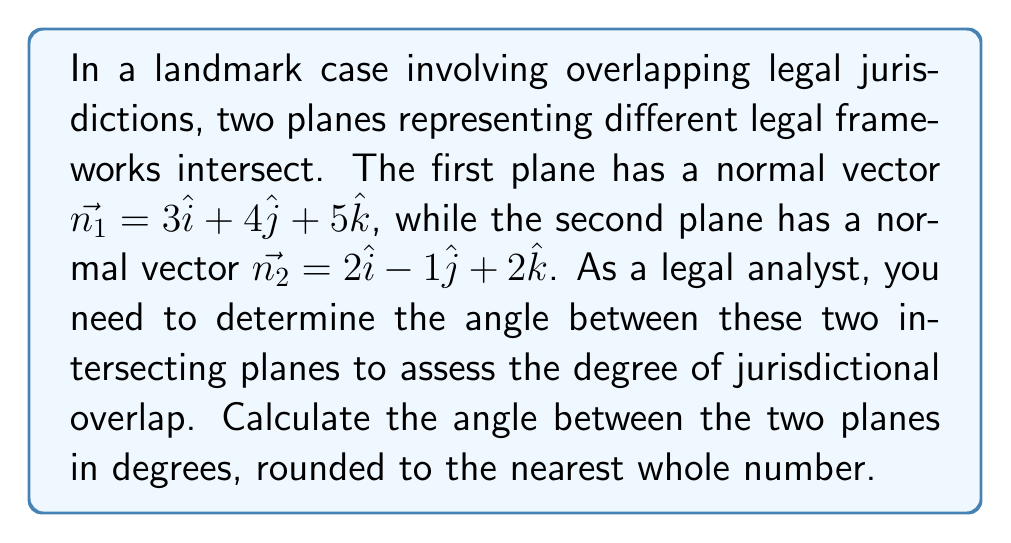What is the answer to this math problem? To find the angle between two intersecting planes, we can use the angle between their normal vectors. The formula for the angle $\theta$ between two vectors $\vec{a}$ and $\vec{b}$ is:

$$\cos \theta = \frac{\vec{a} \cdot \vec{b}}{|\vec{a}||\vec{b}|}$$

Step 1: Calculate the dot product of the normal vectors.
$$\vec{n_1} \cdot \vec{n_2} = (3)(2) + (4)(-1) + (5)(2) = 6 - 4 + 10 = 12$$

Step 2: Calculate the magnitudes of the normal vectors.
$$|\vec{n_1}| = \sqrt{3^2 + 4^2 + 5^2} = \sqrt{50}$$
$$|\vec{n_2}| = \sqrt{2^2 + (-1)^2 + 2^2} = \sqrt{9} = 3$$

Step 3: Apply the formula for the angle between vectors.
$$\cos \theta = \frac{12}{\sqrt{50} \cdot 3}$$

Step 4: Solve for $\theta$ using the inverse cosine function.
$$\theta = \arccos\left(\frac{12}{\sqrt{50} \cdot 3}\right)$$

Step 5: Convert the result to degrees and round to the nearest whole number.
$$\theta \approx 44.4^\circ \approx 44^\circ$$

The angle between the two planes is approximately 44°.
Answer: 44° 